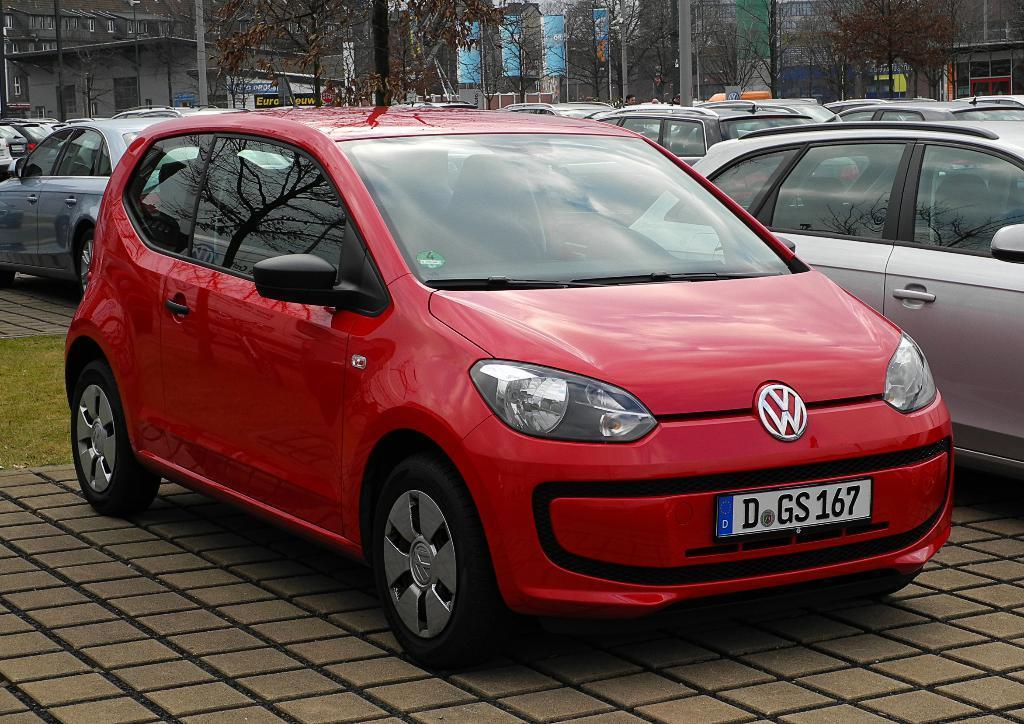Please provide a concise description of this image. In this image, we can see vehicles on the road and in the background, there are trees, buildings, boards and poles and banners. 